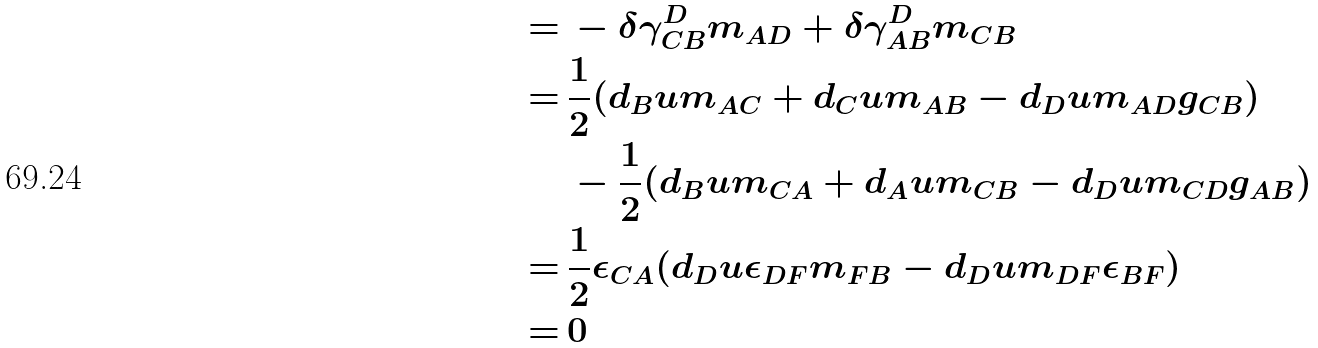Convert formula to latex. <formula><loc_0><loc_0><loc_500><loc_500>= \, & - \delta \gamma ^ { D } _ { C B } m _ { A D } + \delta \gamma ^ { D } _ { A B } m _ { C B } \\ = \, & \frac { 1 } { 2 } ( d _ { B } u m _ { A C } + d _ { C } u m _ { A B } - d _ { D } u m _ { A D } g _ { C B } ) \\ & - \frac { 1 } { 2 } ( d _ { B } u m _ { C A } + d _ { A } u m _ { C B } - d _ { D } u m _ { C D } g _ { A B } ) \\ = \, & \frac { 1 } { 2 } \epsilon _ { C A } ( d _ { D } u \epsilon _ { D F } m _ { F B } - d _ { D } u m _ { D F } \epsilon _ { B F } ) \\ = \, & 0</formula> 